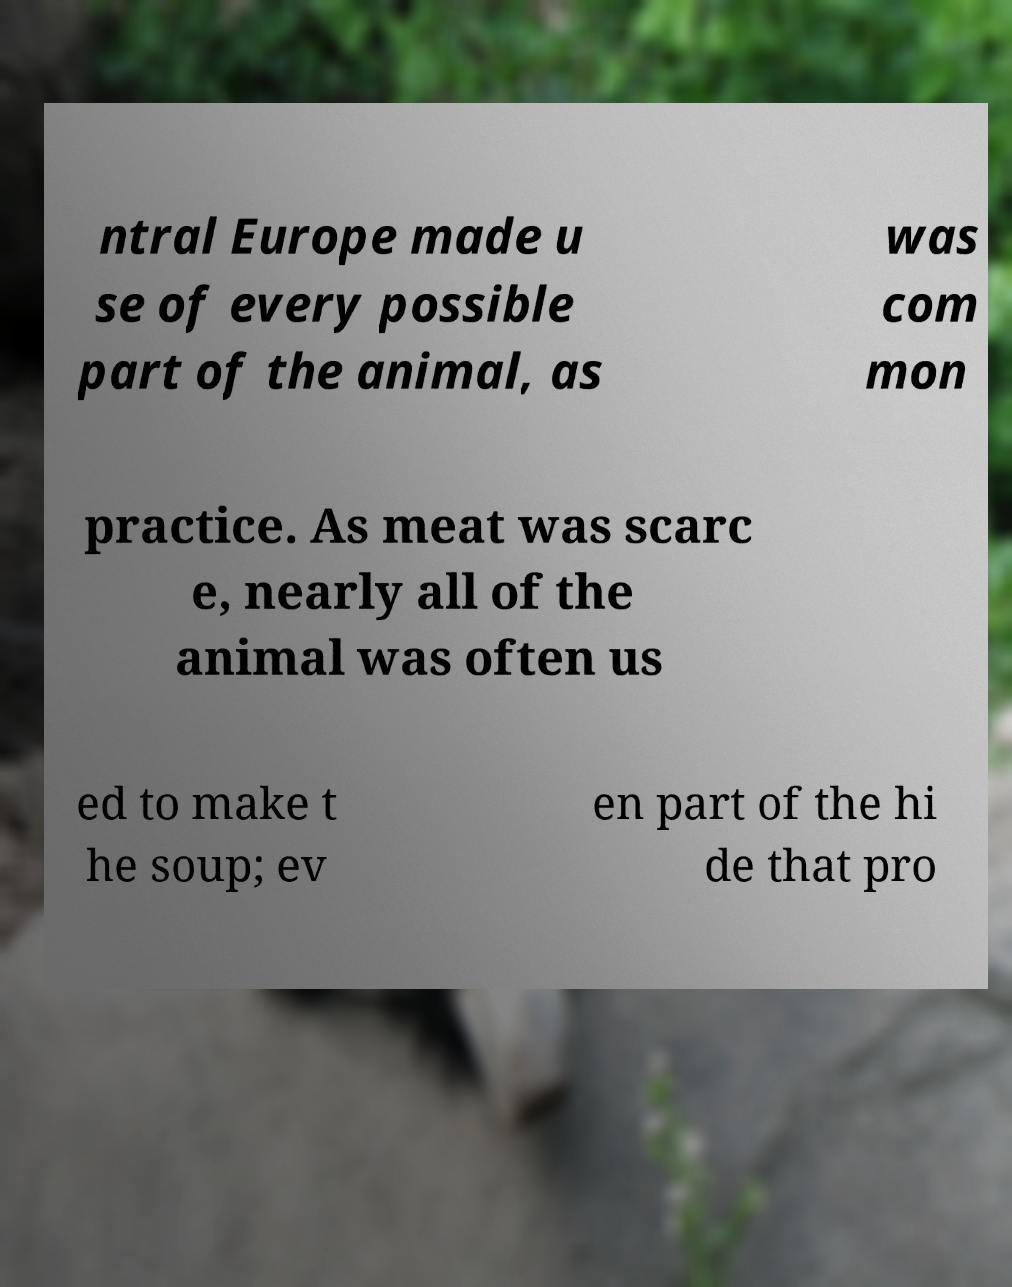Could you assist in decoding the text presented in this image and type it out clearly? ntral Europe made u se of every possible part of the animal, as was com mon practice. As meat was scarc e, nearly all of the animal was often us ed to make t he soup; ev en part of the hi de that pro 